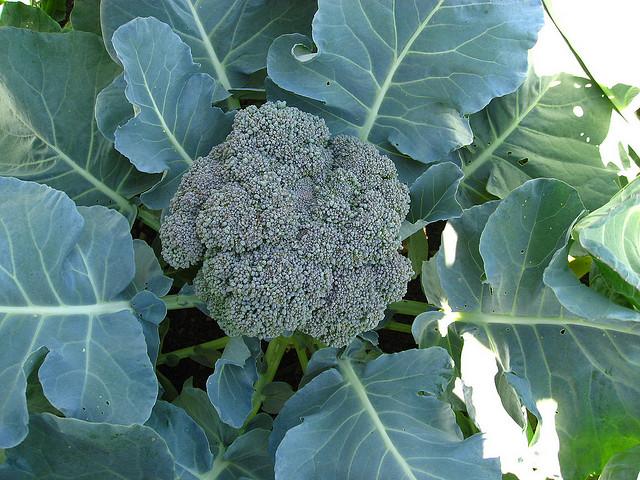How many leaves have water drops on them?
Keep it brief. 0. Is this an edible plant?
Concise answer only. Yes. What is the season, winter, fall, summer or spring?
Give a very brief answer. Summer. What color is the vegetable?
Concise answer only. Green. What kind of plant is this?
Give a very brief answer. Broccoli. Is this a cauliflower?
Give a very brief answer. No. 